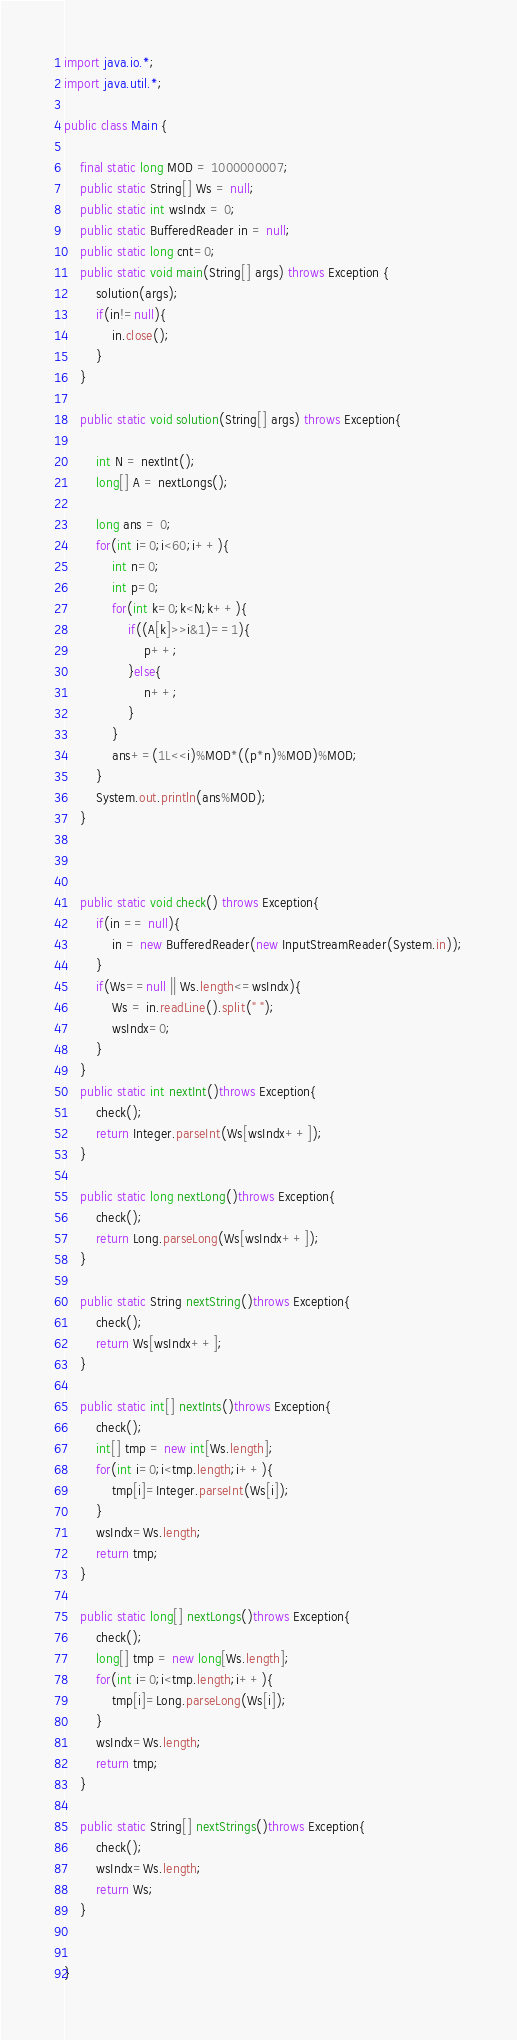Convert code to text. <code><loc_0><loc_0><loc_500><loc_500><_Java_>import java.io.*;
import java.util.*;

public class Main {

	final static long MOD = 1000000007;
	public static String[] Ws = null;
	public static int wsIndx = 0;
	public static BufferedReader in = null;
	public static long cnt=0;
	public static void main(String[] args) throws Exception {
		solution(args);
		if(in!=null){
			in.close();
		}
	}

	public static void solution(String[] args) throws Exception{

		int N = nextInt();
		long[] A = nextLongs();

		long ans = 0;
		for(int i=0;i<60;i++){
			int n=0;
			int p=0;
			for(int k=0;k<N;k++){
				if((A[k]>>i&1)==1){
					p++;
				}else{
					n++;
				}
			}
			ans+=(1L<<i)%MOD*((p*n)%MOD)%MOD;
		}
		System.out.println(ans%MOD);
	}



	public static void check() throws Exception{
		if(in == null){
			in = new BufferedReader(new InputStreamReader(System.in));
		}
		if(Ws==null || Ws.length<=wsIndx){
			Ws = in.readLine().split(" ");
			wsIndx=0;
		}
	}
	public static int nextInt()throws Exception{
		check();
		return Integer.parseInt(Ws[wsIndx++]);
	}

	public static long nextLong()throws Exception{
		check();
		return Long.parseLong(Ws[wsIndx++]);
	}

	public static String nextString()throws Exception{
		check();
		return Ws[wsIndx++];
	}

	public static int[] nextInts()throws Exception{
		check();
		int[] tmp = new int[Ws.length];
		for(int i=0;i<tmp.length;i++){
			tmp[i]=Integer.parseInt(Ws[i]);
		}
		wsIndx=Ws.length;
		return tmp;
	}

	public static long[] nextLongs()throws Exception{
		check();
		long[] tmp = new long[Ws.length];
		for(int i=0;i<tmp.length;i++){
			tmp[i]=Long.parseLong(Ws[i]);
		}
		wsIndx=Ws.length;
		return tmp;
	}

	public static String[] nextStrings()throws Exception{
		check();
		wsIndx=Ws.length;
		return Ws;
	}


}
</code> 